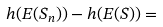Convert formula to latex. <formula><loc_0><loc_0><loc_500><loc_500>h ( E ( S _ { n } ) ) - h ( E ( S ) ) =</formula> 